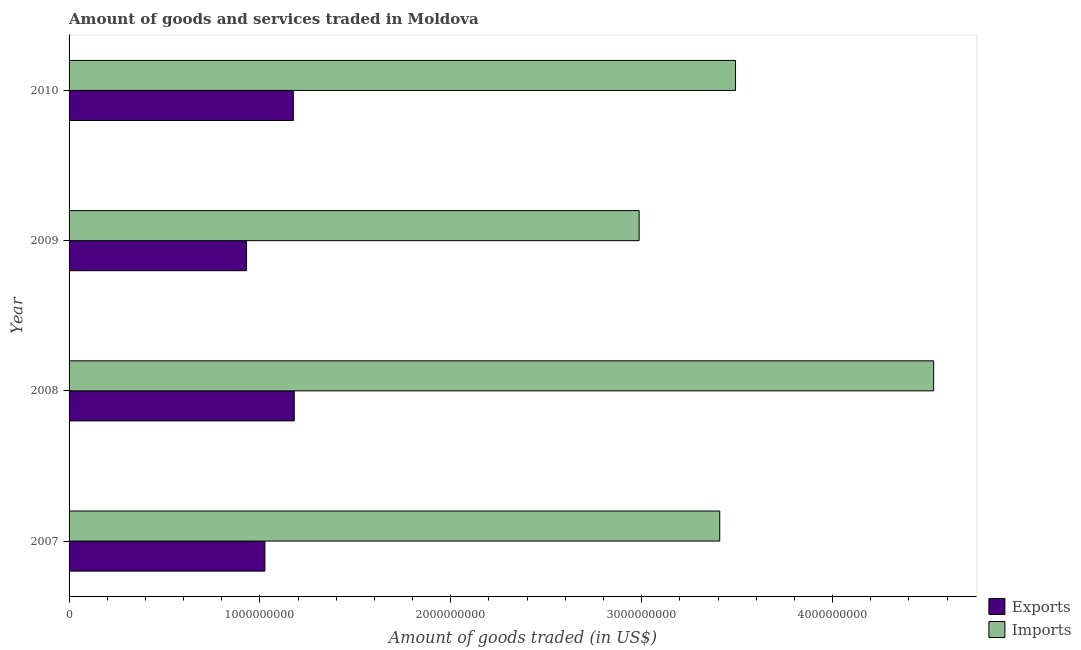How many different coloured bars are there?
Give a very brief answer. 2. Are the number of bars per tick equal to the number of legend labels?
Give a very brief answer. Yes. How many bars are there on the 3rd tick from the bottom?
Your response must be concise. 2. What is the amount of goods imported in 2008?
Your answer should be compact. 4.53e+09. Across all years, what is the maximum amount of goods imported?
Ensure brevity in your answer.  4.53e+09. Across all years, what is the minimum amount of goods exported?
Provide a succinct answer. 9.30e+08. In which year was the amount of goods imported minimum?
Give a very brief answer. 2009. What is the total amount of goods imported in the graph?
Ensure brevity in your answer.  1.44e+1. What is the difference between the amount of goods imported in 2008 and that in 2009?
Give a very brief answer. 1.54e+09. What is the difference between the amount of goods imported in 2008 and the amount of goods exported in 2007?
Your answer should be compact. 3.50e+09. What is the average amount of goods exported per year?
Offer a terse response. 1.08e+09. In the year 2010, what is the difference between the amount of goods imported and amount of goods exported?
Your answer should be compact. 2.32e+09. In how many years, is the amount of goods imported greater than 4000000000 US$?
Keep it short and to the point. 1. What is the ratio of the amount of goods imported in 2007 to that in 2009?
Offer a very short reply. 1.14. Is the amount of goods exported in 2007 less than that in 2010?
Make the answer very short. Yes. What is the difference between the highest and the second highest amount of goods exported?
Provide a succinct answer. 4.72e+06. What is the difference between the highest and the lowest amount of goods imported?
Offer a terse response. 1.54e+09. What does the 1st bar from the top in 2008 represents?
Provide a succinct answer. Imports. What does the 1st bar from the bottom in 2008 represents?
Provide a succinct answer. Exports. How many years are there in the graph?
Your response must be concise. 4. Are the values on the major ticks of X-axis written in scientific E-notation?
Your response must be concise. No. How are the legend labels stacked?
Your answer should be compact. Vertical. What is the title of the graph?
Your response must be concise. Amount of goods and services traded in Moldova. Does "By country of origin" appear as one of the legend labels in the graph?
Make the answer very short. No. What is the label or title of the X-axis?
Your answer should be very brief. Amount of goods traded (in US$). What is the Amount of goods traded (in US$) in Exports in 2007?
Offer a terse response. 1.03e+09. What is the Amount of goods traded (in US$) in Imports in 2007?
Your answer should be compact. 3.41e+09. What is the Amount of goods traded (in US$) of Exports in 2008?
Ensure brevity in your answer.  1.18e+09. What is the Amount of goods traded (in US$) of Imports in 2008?
Provide a short and direct response. 4.53e+09. What is the Amount of goods traded (in US$) in Exports in 2009?
Provide a succinct answer. 9.30e+08. What is the Amount of goods traded (in US$) of Imports in 2009?
Your answer should be very brief. 2.99e+09. What is the Amount of goods traded (in US$) of Exports in 2010?
Your response must be concise. 1.18e+09. What is the Amount of goods traded (in US$) in Imports in 2010?
Give a very brief answer. 3.49e+09. Across all years, what is the maximum Amount of goods traded (in US$) of Exports?
Offer a terse response. 1.18e+09. Across all years, what is the maximum Amount of goods traded (in US$) of Imports?
Provide a succinct answer. 4.53e+09. Across all years, what is the minimum Amount of goods traded (in US$) in Exports?
Give a very brief answer. 9.30e+08. Across all years, what is the minimum Amount of goods traded (in US$) of Imports?
Make the answer very short. 2.99e+09. What is the total Amount of goods traded (in US$) in Exports in the graph?
Your response must be concise. 4.31e+09. What is the total Amount of goods traded (in US$) of Imports in the graph?
Your answer should be compact. 1.44e+1. What is the difference between the Amount of goods traded (in US$) of Exports in 2007 and that in 2008?
Keep it short and to the point. -1.54e+08. What is the difference between the Amount of goods traded (in US$) in Imports in 2007 and that in 2008?
Your answer should be very brief. -1.12e+09. What is the difference between the Amount of goods traded (in US$) of Exports in 2007 and that in 2009?
Your answer should be very brief. 9.62e+07. What is the difference between the Amount of goods traded (in US$) in Imports in 2007 and that in 2009?
Offer a terse response. 4.22e+08. What is the difference between the Amount of goods traded (in US$) in Exports in 2007 and that in 2010?
Provide a succinct answer. -1.49e+08. What is the difference between the Amount of goods traded (in US$) of Imports in 2007 and that in 2010?
Make the answer very short. -8.27e+07. What is the difference between the Amount of goods traded (in US$) of Exports in 2008 and that in 2009?
Your answer should be compact. 2.50e+08. What is the difference between the Amount of goods traded (in US$) of Imports in 2008 and that in 2009?
Provide a short and direct response. 1.54e+09. What is the difference between the Amount of goods traded (in US$) in Exports in 2008 and that in 2010?
Make the answer very short. 4.72e+06. What is the difference between the Amount of goods traded (in US$) in Imports in 2008 and that in 2010?
Ensure brevity in your answer.  1.04e+09. What is the difference between the Amount of goods traded (in US$) in Exports in 2009 and that in 2010?
Offer a terse response. -2.45e+08. What is the difference between the Amount of goods traded (in US$) in Imports in 2009 and that in 2010?
Offer a terse response. -5.05e+08. What is the difference between the Amount of goods traded (in US$) of Exports in 2007 and the Amount of goods traded (in US$) of Imports in 2008?
Give a very brief answer. -3.50e+09. What is the difference between the Amount of goods traded (in US$) in Exports in 2007 and the Amount of goods traded (in US$) in Imports in 2009?
Offer a very short reply. -1.96e+09. What is the difference between the Amount of goods traded (in US$) in Exports in 2007 and the Amount of goods traded (in US$) in Imports in 2010?
Provide a succinct answer. -2.47e+09. What is the difference between the Amount of goods traded (in US$) of Exports in 2008 and the Amount of goods traded (in US$) of Imports in 2009?
Offer a very short reply. -1.81e+09. What is the difference between the Amount of goods traded (in US$) in Exports in 2008 and the Amount of goods traded (in US$) in Imports in 2010?
Your answer should be very brief. -2.31e+09. What is the difference between the Amount of goods traded (in US$) of Exports in 2009 and the Amount of goods traded (in US$) of Imports in 2010?
Provide a succinct answer. -2.56e+09. What is the average Amount of goods traded (in US$) in Exports per year?
Ensure brevity in your answer.  1.08e+09. What is the average Amount of goods traded (in US$) of Imports per year?
Provide a short and direct response. 3.60e+09. In the year 2007, what is the difference between the Amount of goods traded (in US$) of Exports and Amount of goods traded (in US$) of Imports?
Your answer should be compact. -2.38e+09. In the year 2008, what is the difference between the Amount of goods traded (in US$) in Exports and Amount of goods traded (in US$) in Imports?
Provide a succinct answer. -3.35e+09. In the year 2009, what is the difference between the Amount of goods traded (in US$) in Exports and Amount of goods traded (in US$) in Imports?
Offer a very short reply. -2.06e+09. In the year 2010, what is the difference between the Amount of goods traded (in US$) of Exports and Amount of goods traded (in US$) of Imports?
Your response must be concise. -2.32e+09. What is the ratio of the Amount of goods traded (in US$) in Exports in 2007 to that in 2008?
Offer a very short reply. 0.87. What is the ratio of the Amount of goods traded (in US$) of Imports in 2007 to that in 2008?
Your answer should be compact. 0.75. What is the ratio of the Amount of goods traded (in US$) in Exports in 2007 to that in 2009?
Give a very brief answer. 1.1. What is the ratio of the Amount of goods traded (in US$) in Imports in 2007 to that in 2009?
Offer a very short reply. 1.14. What is the ratio of the Amount of goods traded (in US$) of Exports in 2007 to that in 2010?
Provide a short and direct response. 0.87. What is the ratio of the Amount of goods traded (in US$) of Imports in 2007 to that in 2010?
Make the answer very short. 0.98. What is the ratio of the Amount of goods traded (in US$) in Exports in 2008 to that in 2009?
Give a very brief answer. 1.27. What is the ratio of the Amount of goods traded (in US$) in Imports in 2008 to that in 2009?
Your answer should be very brief. 1.52. What is the ratio of the Amount of goods traded (in US$) of Exports in 2008 to that in 2010?
Your answer should be compact. 1. What is the ratio of the Amount of goods traded (in US$) in Imports in 2008 to that in 2010?
Give a very brief answer. 1.3. What is the ratio of the Amount of goods traded (in US$) in Exports in 2009 to that in 2010?
Keep it short and to the point. 0.79. What is the ratio of the Amount of goods traded (in US$) of Imports in 2009 to that in 2010?
Your answer should be compact. 0.86. What is the difference between the highest and the second highest Amount of goods traded (in US$) in Exports?
Keep it short and to the point. 4.72e+06. What is the difference between the highest and the second highest Amount of goods traded (in US$) in Imports?
Provide a succinct answer. 1.04e+09. What is the difference between the highest and the lowest Amount of goods traded (in US$) of Exports?
Provide a short and direct response. 2.50e+08. What is the difference between the highest and the lowest Amount of goods traded (in US$) in Imports?
Your response must be concise. 1.54e+09. 